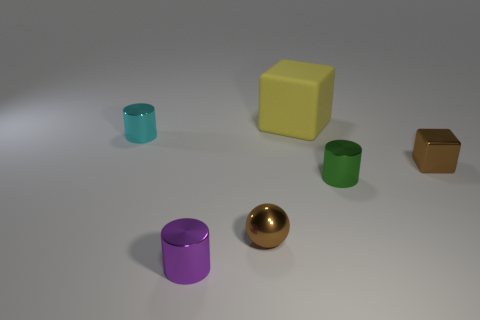Add 1 brown matte objects. How many objects exist? 7 Subtract all tiny purple metal cylinders. How many cylinders are left? 2 Subtract 1 cylinders. How many cylinders are left? 2 Subtract all blocks. How many objects are left? 4 Subtract all cyan cylinders. How many cylinders are left? 2 Add 6 yellow blocks. How many yellow blocks exist? 7 Subtract 1 green cylinders. How many objects are left? 5 Subtract all cyan blocks. Subtract all green cylinders. How many blocks are left? 2 Subtract all large yellow things. Subtract all blue cubes. How many objects are left? 5 Add 3 brown metallic spheres. How many brown metallic spheres are left? 4 